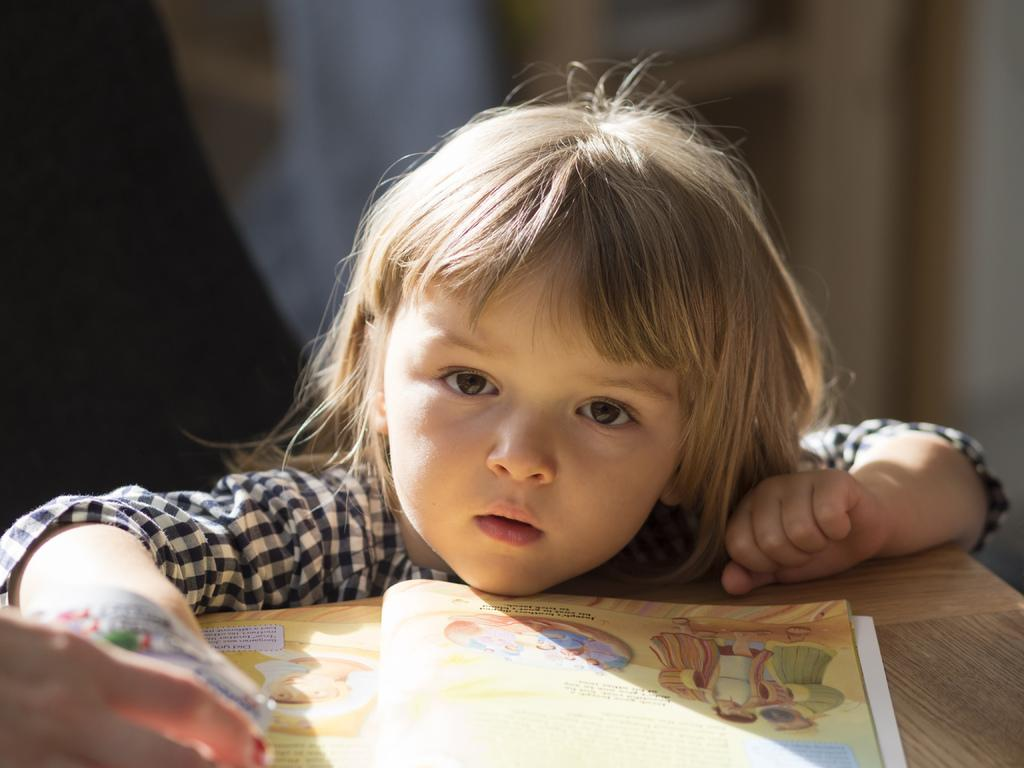Who is present in the image? There is a child in the image. Where is the child located in relation to the table? The child is beside the table. What is on the table in the image? There is a book on the table. Can you describe the hand and object at the bottom left of the image? There is a hand holding an object at the bottom left of the image. What type of insurance does the child's friend have in the image? There is no friend or mention of insurance in the image. Can you tell me how many hens are visible in the image? There are no hens present in the image. 